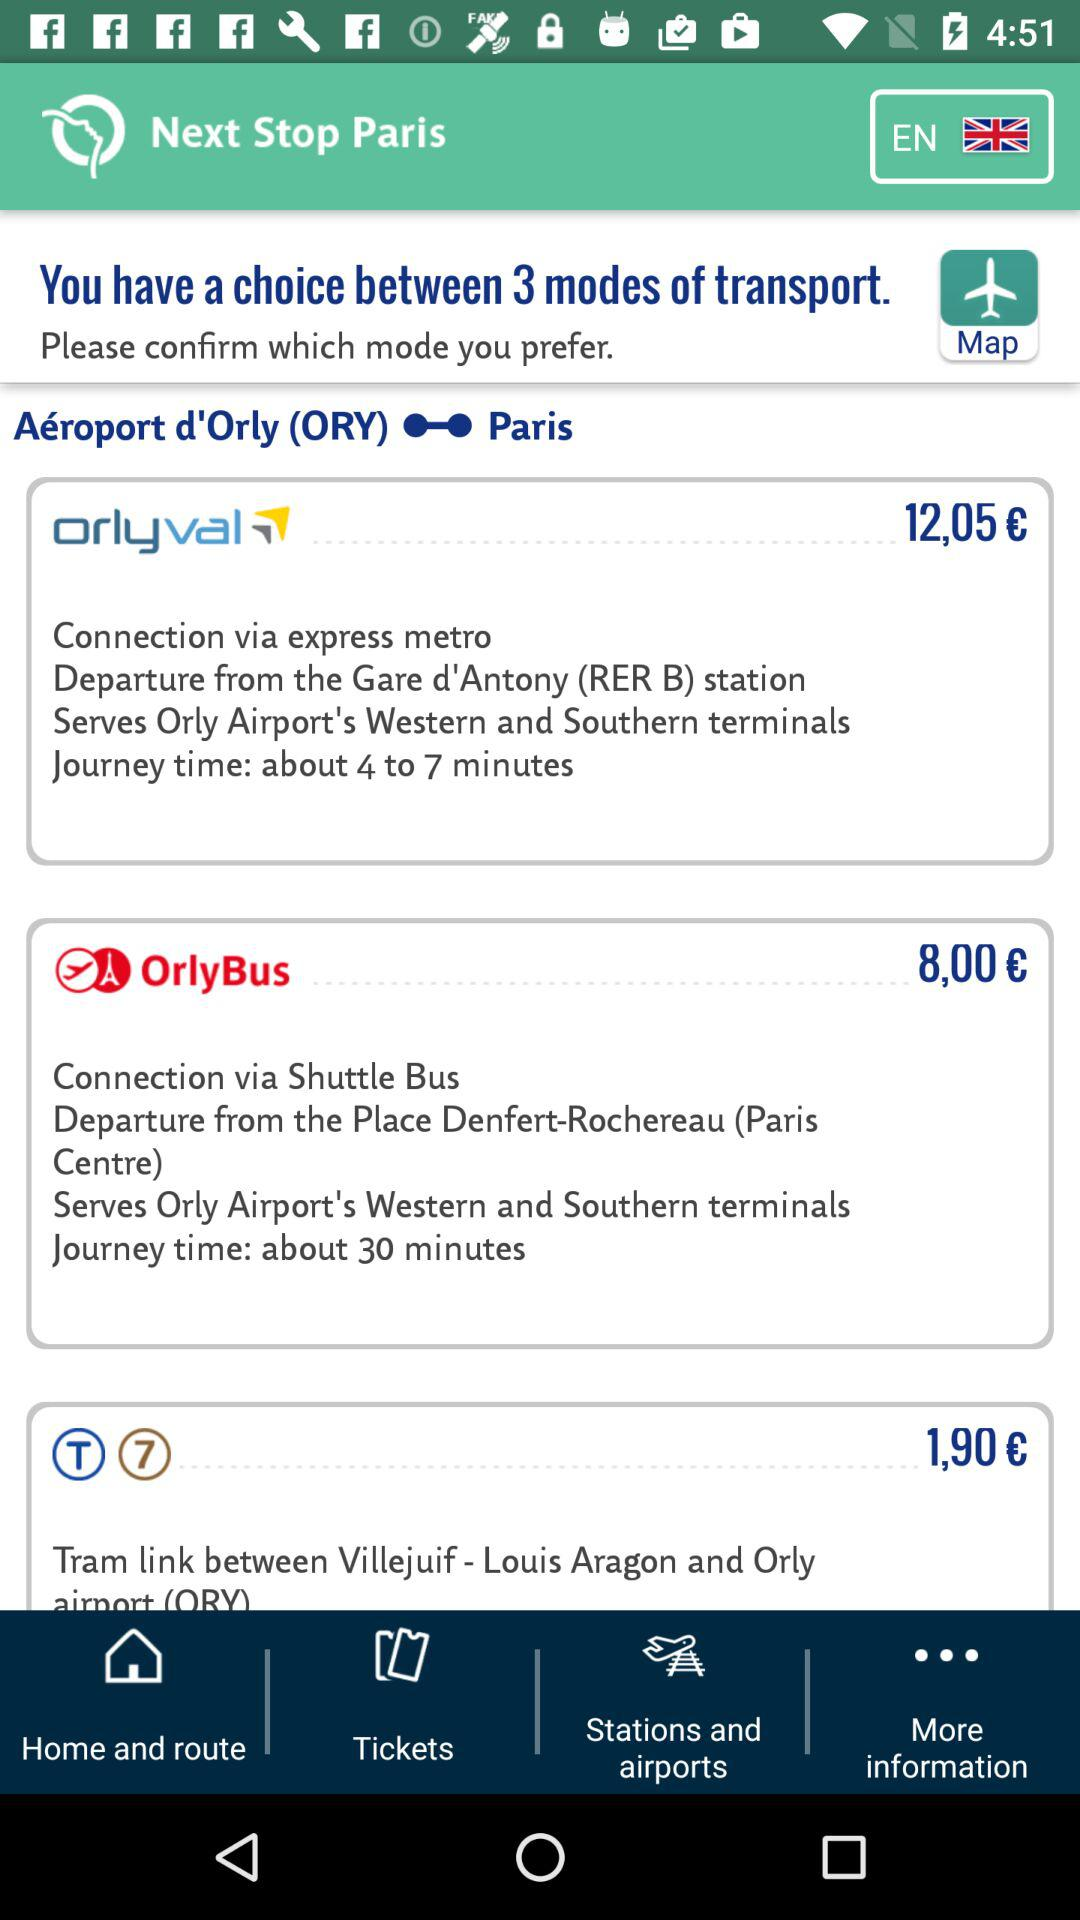How many modes of transport are available for this trip?
Answer the question using a single word or phrase. 3 